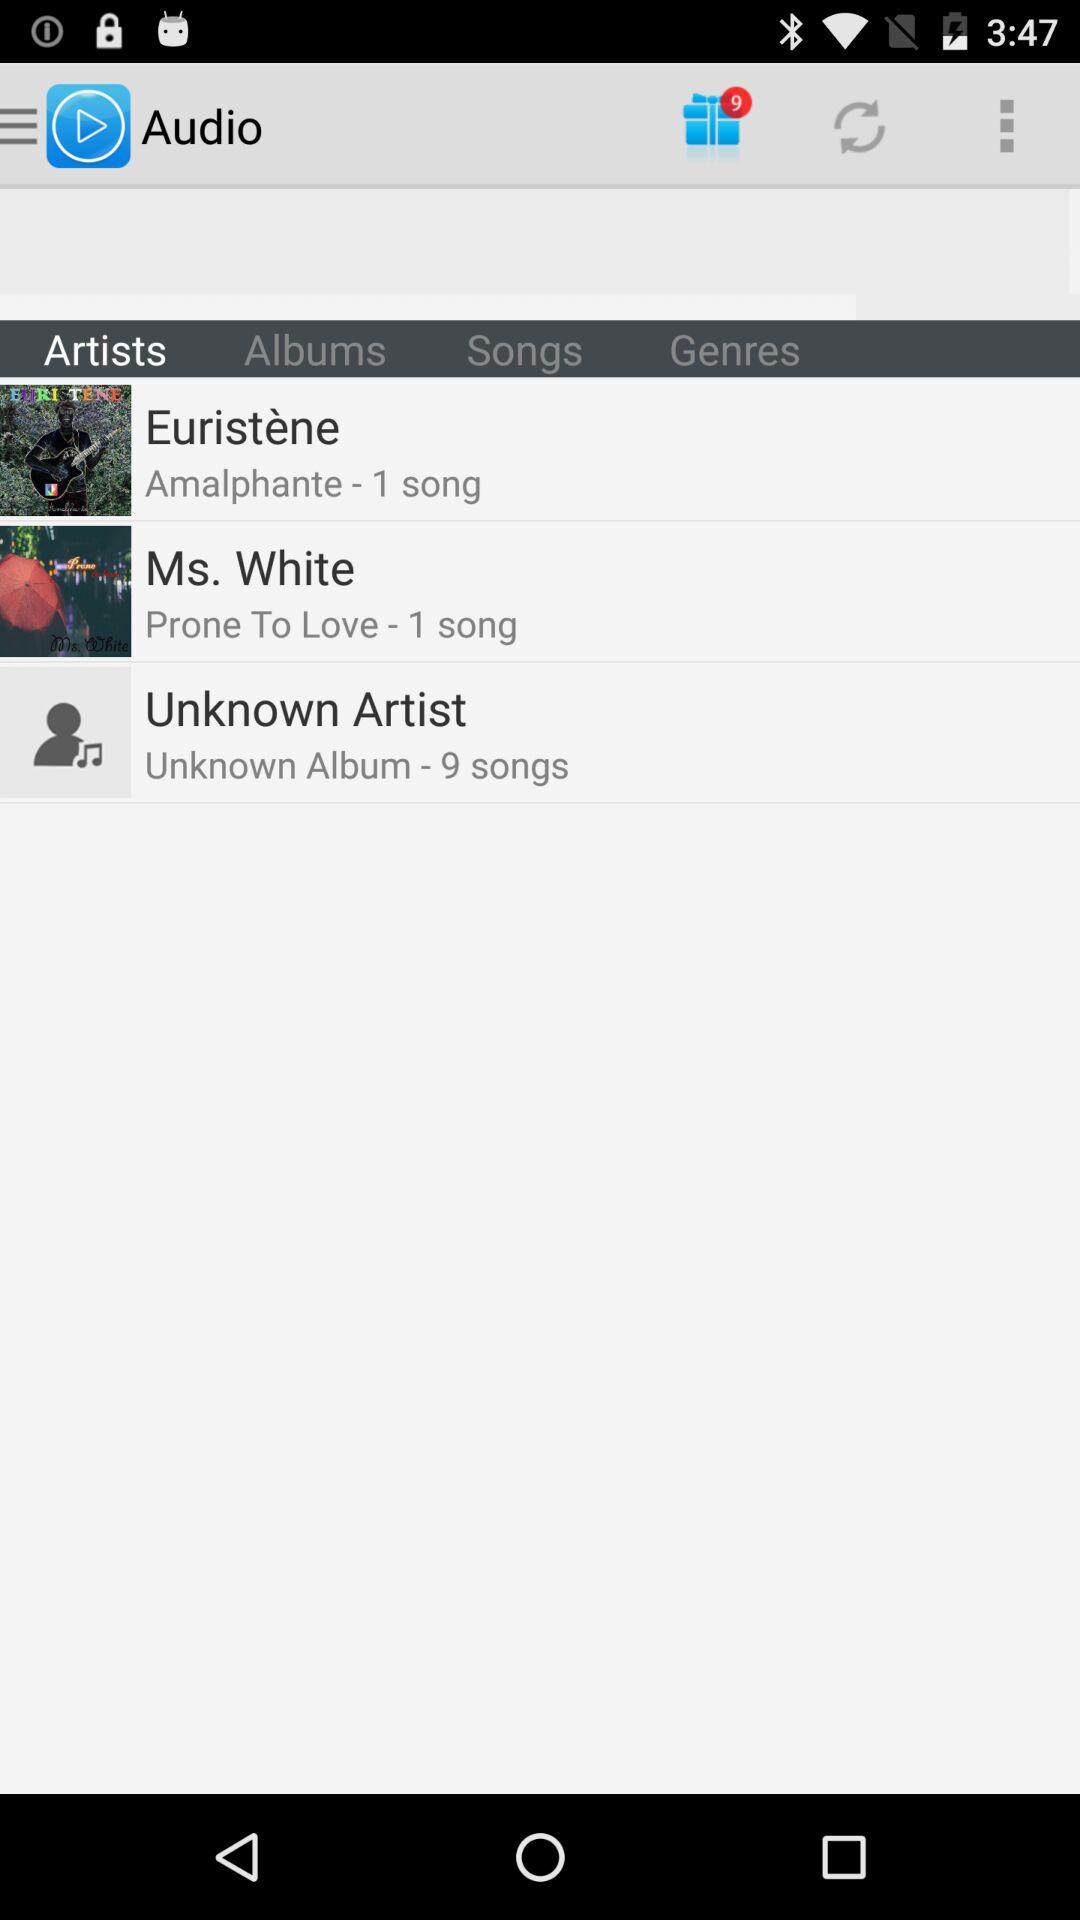How many more songs are in the album with the unknown artist than the album with Ms. White?
Answer the question using a single word or phrase. 8 